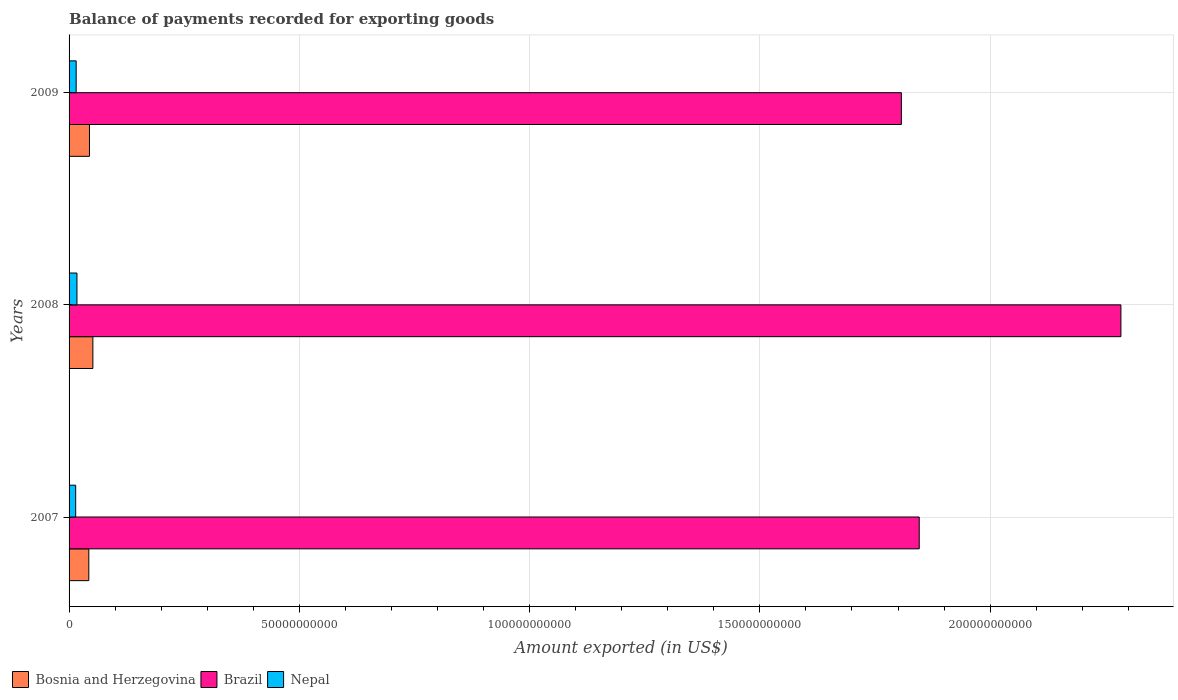How many different coloured bars are there?
Make the answer very short. 3. How many groups of bars are there?
Make the answer very short. 3. Are the number of bars on each tick of the Y-axis equal?
Give a very brief answer. Yes. In how many cases, is the number of bars for a given year not equal to the number of legend labels?
Keep it short and to the point. 0. What is the amount exported in Bosnia and Herzegovina in 2008?
Offer a terse response. 5.17e+09. Across all years, what is the maximum amount exported in Bosnia and Herzegovina?
Keep it short and to the point. 5.17e+09. Across all years, what is the minimum amount exported in Bosnia and Herzegovina?
Your answer should be compact. 4.29e+09. What is the total amount exported in Nepal in the graph?
Your response must be concise. 4.69e+09. What is the difference between the amount exported in Brazil in 2008 and that in 2009?
Provide a short and direct response. 4.77e+1. What is the difference between the amount exported in Nepal in 2009 and the amount exported in Brazil in 2007?
Your answer should be compact. -1.83e+11. What is the average amount exported in Brazil per year?
Make the answer very short. 1.98e+11. In the year 2009, what is the difference between the amount exported in Brazil and amount exported in Nepal?
Give a very brief answer. 1.79e+11. What is the ratio of the amount exported in Bosnia and Herzegovina in 2007 to that in 2009?
Offer a very short reply. 0.97. What is the difference between the highest and the second highest amount exported in Nepal?
Give a very brief answer. 1.68e+08. What is the difference between the highest and the lowest amount exported in Brazil?
Offer a terse response. 4.77e+1. Is the sum of the amount exported in Brazil in 2007 and 2008 greater than the maximum amount exported in Nepal across all years?
Your response must be concise. Yes. What does the 3rd bar from the bottom in 2009 represents?
Provide a short and direct response. Nepal. How many bars are there?
Give a very brief answer. 9. Are all the bars in the graph horizontal?
Provide a succinct answer. Yes. What is the difference between two consecutive major ticks on the X-axis?
Provide a succinct answer. 5.00e+1. Does the graph contain grids?
Offer a very short reply. Yes. What is the title of the graph?
Your response must be concise. Balance of payments recorded for exporting goods. Does "Israel" appear as one of the legend labels in the graph?
Keep it short and to the point. No. What is the label or title of the X-axis?
Provide a short and direct response. Amount exported (in US$). What is the Amount exported (in US$) in Bosnia and Herzegovina in 2007?
Provide a succinct answer. 4.29e+09. What is the Amount exported (in US$) of Brazil in 2007?
Provide a succinct answer. 1.85e+11. What is the Amount exported (in US$) of Nepal in 2007?
Ensure brevity in your answer.  1.44e+09. What is the Amount exported (in US$) in Bosnia and Herzegovina in 2008?
Your response must be concise. 5.17e+09. What is the Amount exported (in US$) in Brazil in 2008?
Give a very brief answer. 2.28e+11. What is the Amount exported (in US$) in Nepal in 2008?
Provide a short and direct response. 1.71e+09. What is the Amount exported (in US$) of Bosnia and Herzegovina in 2009?
Provide a succinct answer. 4.43e+09. What is the Amount exported (in US$) in Brazil in 2009?
Make the answer very short. 1.81e+11. What is the Amount exported (in US$) in Nepal in 2009?
Offer a terse response. 1.54e+09. Across all years, what is the maximum Amount exported (in US$) of Bosnia and Herzegovina?
Provide a succinct answer. 5.17e+09. Across all years, what is the maximum Amount exported (in US$) of Brazil?
Your answer should be very brief. 2.28e+11. Across all years, what is the maximum Amount exported (in US$) of Nepal?
Your answer should be very brief. 1.71e+09. Across all years, what is the minimum Amount exported (in US$) of Bosnia and Herzegovina?
Give a very brief answer. 4.29e+09. Across all years, what is the minimum Amount exported (in US$) of Brazil?
Keep it short and to the point. 1.81e+11. Across all years, what is the minimum Amount exported (in US$) of Nepal?
Keep it short and to the point. 1.44e+09. What is the total Amount exported (in US$) of Bosnia and Herzegovina in the graph?
Provide a succinct answer. 1.39e+1. What is the total Amount exported (in US$) in Brazil in the graph?
Give a very brief answer. 5.94e+11. What is the total Amount exported (in US$) of Nepal in the graph?
Your answer should be compact. 4.69e+09. What is the difference between the Amount exported (in US$) of Bosnia and Herzegovina in 2007 and that in 2008?
Give a very brief answer. -8.81e+08. What is the difference between the Amount exported (in US$) of Brazil in 2007 and that in 2008?
Provide a succinct answer. -4.38e+1. What is the difference between the Amount exported (in US$) of Nepal in 2007 and that in 2008?
Your answer should be compact. -2.74e+08. What is the difference between the Amount exported (in US$) of Bosnia and Herzegovina in 2007 and that in 2009?
Keep it short and to the point. -1.43e+08. What is the difference between the Amount exported (in US$) in Brazil in 2007 and that in 2009?
Your answer should be compact. 3.88e+09. What is the difference between the Amount exported (in US$) in Nepal in 2007 and that in 2009?
Provide a succinct answer. -1.06e+08. What is the difference between the Amount exported (in US$) in Bosnia and Herzegovina in 2008 and that in 2009?
Give a very brief answer. 7.38e+08. What is the difference between the Amount exported (in US$) in Brazil in 2008 and that in 2009?
Provide a short and direct response. 4.77e+1. What is the difference between the Amount exported (in US$) of Nepal in 2008 and that in 2009?
Make the answer very short. 1.68e+08. What is the difference between the Amount exported (in US$) in Bosnia and Herzegovina in 2007 and the Amount exported (in US$) in Brazil in 2008?
Your answer should be very brief. -2.24e+11. What is the difference between the Amount exported (in US$) in Bosnia and Herzegovina in 2007 and the Amount exported (in US$) in Nepal in 2008?
Ensure brevity in your answer.  2.58e+09. What is the difference between the Amount exported (in US$) of Brazil in 2007 and the Amount exported (in US$) of Nepal in 2008?
Ensure brevity in your answer.  1.83e+11. What is the difference between the Amount exported (in US$) of Bosnia and Herzegovina in 2007 and the Amount exported (in US$) of Brazil in 2009?
Offer a very short reply. -1.76e+11. What is the difference between the Amount exported (in US$) in Bosnia and Herzegovina in 2007 and the Amount exported (in US$) in Nepal in 2009?
Provide a short and direct response. 2.75e+09. What is the difference between the Amount exported (in US$) of Brazil in 2007 and the Amount exported (in US$) of Nepal in 2009?
Give a very brief answer. 1.83e+11. What is the difference between the Amount exported (in US$) in Bosnia and Herzegovina in 2008 and the Amount exported (in US$) in Brazil in 2009?
Ensure brevity in your answer.  -1.76e+11. What is the difference between the Amount exported (in US$) in Bosnia and Herzegovina in 2008 and the Amount exported (in US$) in Nepal in 2009?
Offer a terse response. 3.63e+09. What is the difference between the Amount exported (in US$) of Brazil in 2008 and the Amount exported (in US$) of Nepal in 2009?
Give a very brief answer. 2.27e+11. What is the average Amount exported (in US$) in Bosnia and Herzegovina per year?
Your answer should be compact. 4.63e+09. What is the average Amount exported (in US$) of Brazil per year?
Your answer should be compact. 1.98e+11. What is the average Amount exported (in US$) in Nepal per year?
Your answer should be very brief. 1.56e+09. In the year 2007, what is the difference between the Amount exported (in US$) in Bosnia and Herzegovina and Amount exported (in US$) in Brazil?
Offer a terse response. -1.80e+11. In the year 2007, what is the difference between the Amount exported (in US$) in Bosnia and Herzegovina and Amount exported (in US$) in Nepal?
Offer a terse response. 2.85e+09. In the year 2007, what is the difference between the Amount exported (in US$) of Brazil and Amount exported (in US$) of Nepal?
Offer a terse response. 1.83e+11. In the year 2008, what is the difference between the Amount exported (in US$) of Bosnia and Herzegovina and Amount exported (in US$) of Brazil?
Provide a succinct answer. -2.23e+11. In the year 2008, what is the difference between the Amount exported (in US$) of Bosnia and Herzegovina and Amount exported (in US$) of Nepal?
Your answer should be very brief. 3.46e+09. In the year 2008, what is the difference between the Amount exported (in US$) in Brazil and Amount exported (in US$) in Nepal?
Your response must be concise. 2.27e+11. In the year 2009, what is the difference between the Amount exported (in US$) in Bosnia and Herzegovina and Amount exported (in US$) in Brazil?
Offer a terse response. -1.76e+11. In the year 2009, what is the difference between the Amount exported (in US$) of Bosnia and Herzegovina and Amount exported (in US$) of Nepal?
Keep it short and to the point. 2.89e+09. In the year 2009, what is the difference between the Amount exported (in US$) of Brazil and Amount exported (in US$) of Nepal?
Provide a short and direct response. 1.79e+11. What is the ratio of the Amount exported (in US$) in Bosnia and Herzegovina in 2007 to that in 2008?
Offer a terse response. 0.83. What is the ratio of the Amount exported (in US$) in Brazil in 2007 to that in 2008?
Your answer should be very brief. 0.81. What is the ratio of the Amount exported (in US$) in Nepal in 2007 to that in 2008?
Offer a very short reply. 0.84. What is the ratio of the Amount exported (in US$) in Brazil in 2007 to that in 2009?
Provide a short and direct response. 1.02. What is the ratio of the Amount exported (in US$) in Nepal in 2007 to that in 2009?
Your answer should be very brief. 0.93. What is the ratio of the Amount exported (in US$) of Bosnia and Herzegovina in 2008 to that in 2009?
Offer a very short reply. 1.17. What is the ratio of the Amount exported (in US$) in Brazil in 2008 to that in 2009?
Your answer should be compact. 1.26. What is the ratio of the Amount exported (in US$) in Nepal in 2008 to that in 2009?
Offer a very short reply. 1.11. What is the difference between the highest and the second highest Amount exported (in US$) of Bosnia and Herzegovina?
Make the answer very short. 7.38e+08. What is the difference between the highest and the second highest Amount exported (in US$) of Brazil?
Offer a very short reply. 4.38e+1. What is the difference between the highest and the second highest Amount exported (in US$) of Nepal?
Your answer should be compact. 1.68e+08. What is the difference between the highest and the lowest Amount exported (in US$) of Bosnia and Herzegovina?
Offer a terse response. 8.81e+08. What is the difference between the highest and the lowest Amount exported (in US$) in Brazil?
Give a very brief answer. 4.77e+1. What is the difference between the highest and the lowest Amount exported (in US$) in Nepal?
Provide a short and direct response. 2.74e+08. 